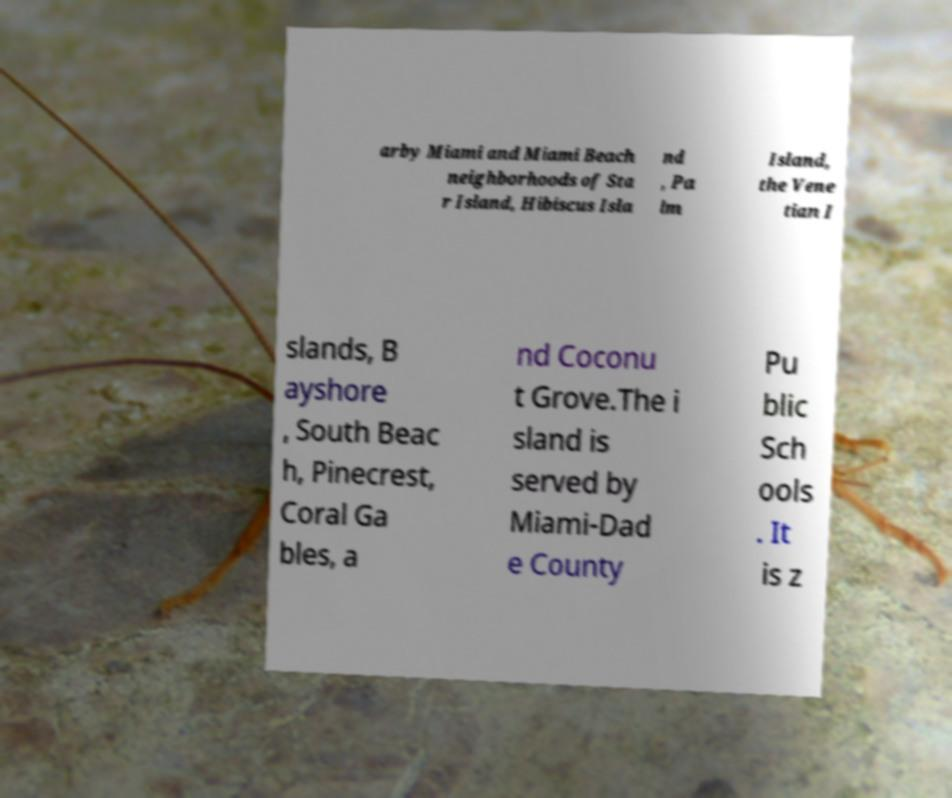I need the written content from this picture converted into text. Can you do that? arby Miami and Miami Beach neighborhoods of Sta r Island, Hibiscus Isla nd , Pa lm Island, the Vene tian I slands, B ayshore , South Beac h, Pinecrest, Coral Ga bles, a nd Coconu t Grove.The i sland is served by Miami-Dad e County Pu blic Sch ools . It is z 